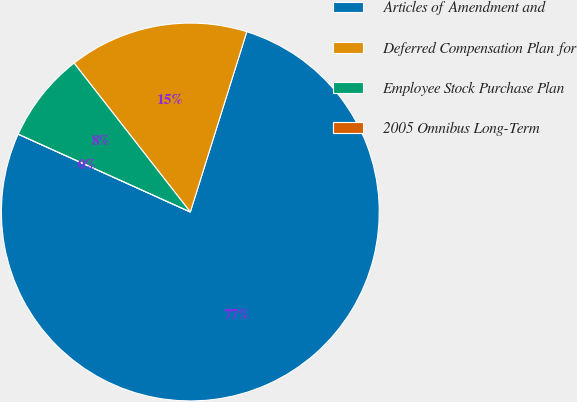Convert chart. <chart><loc_0><loc_0><loc_500><loc_500><pie_chart><fcel>Articles of Amendment and<fcel>Deferred Compensation Plan for<fcel>Employee Stock Purchase Plan<fcel>2005 Omnibus Long-Term<nl><fcel>76.92%<fcel>15.38%<fcel>7.69%<fcel>0.0%<nl></chart> 